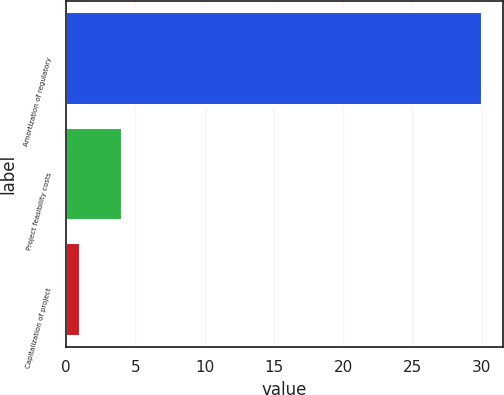Convert chart to OTSL. <chart><loc_0><loc_0><loc_500><loc_500><bar_chart><fcel>Amortization of regulatory<fcel>Project feasibility costs<fcel>Capitalization of project<nl><fcel>30<fcel>4<fcel>1<nl></chart> 